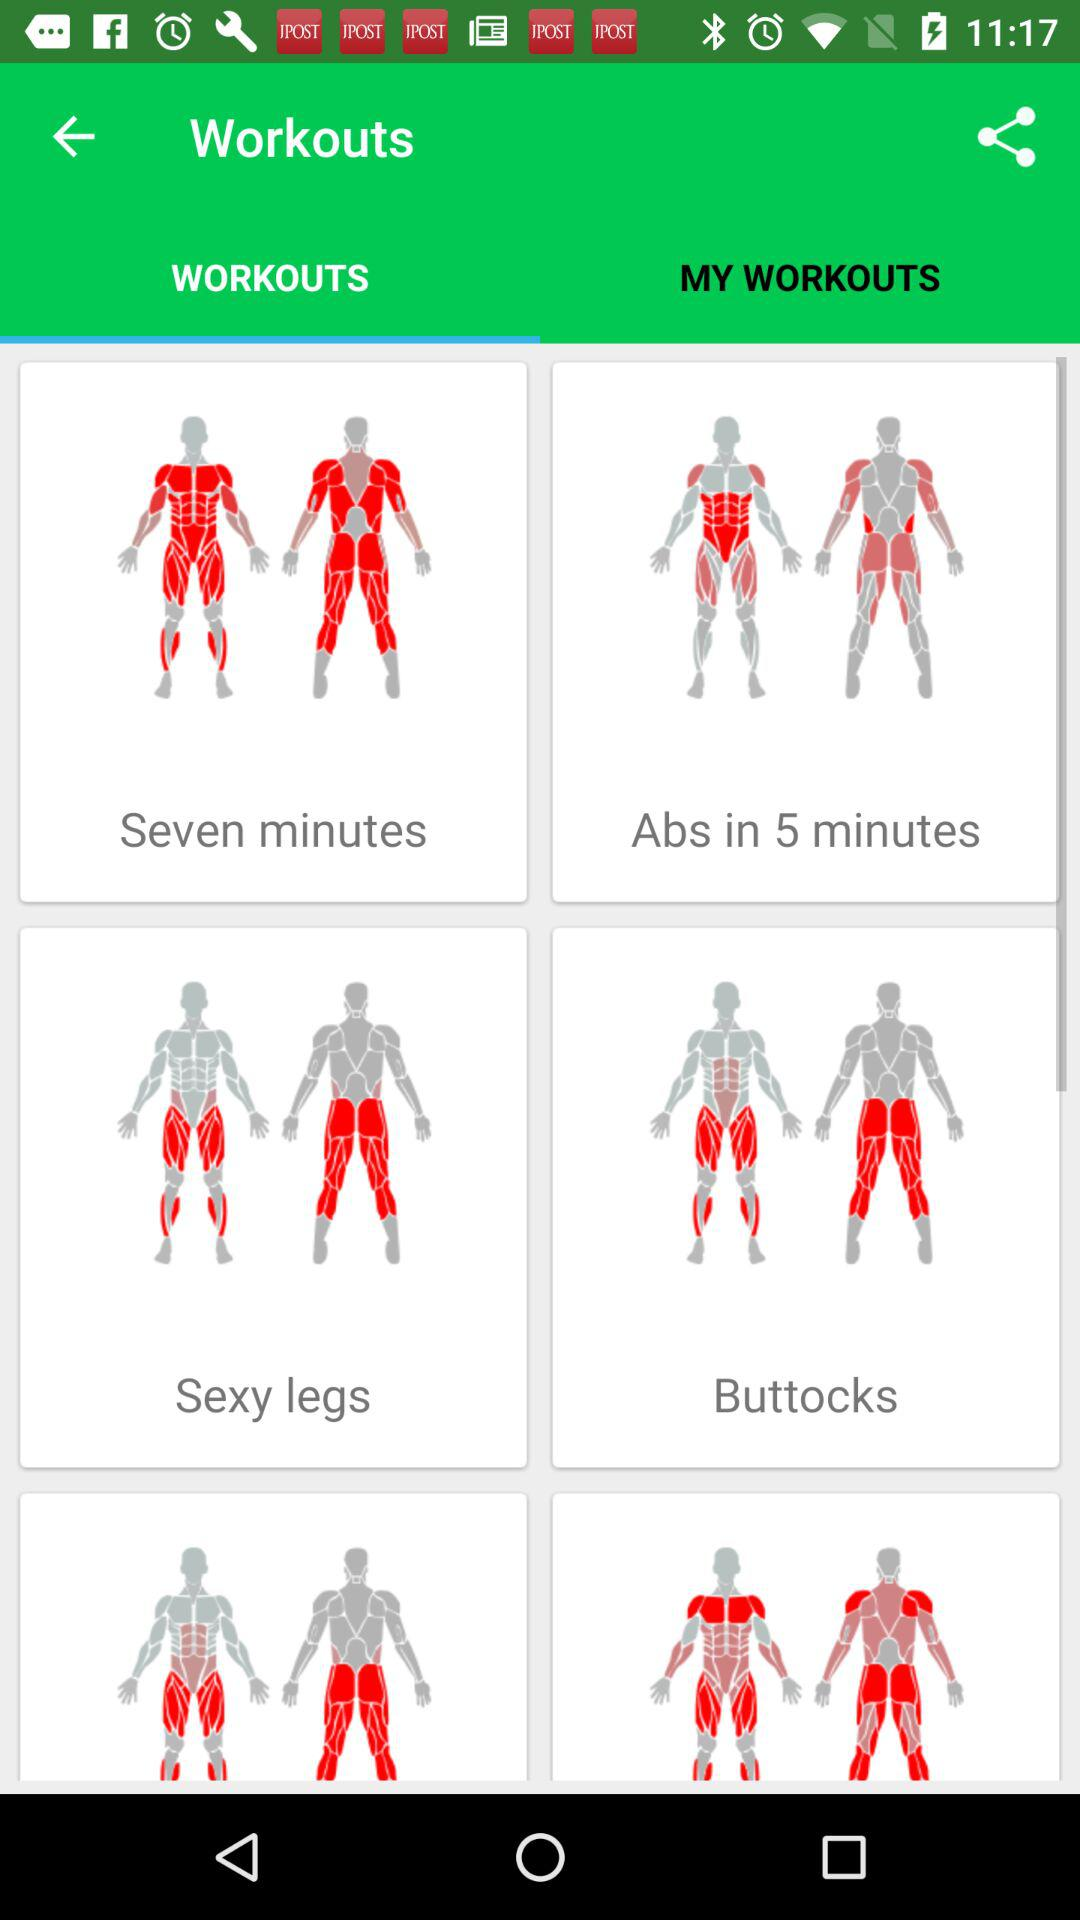Which exercises are listed in "MY WORKOUTS"?
When the provided information is insufficient, respond with <no answer>. <no answer> 